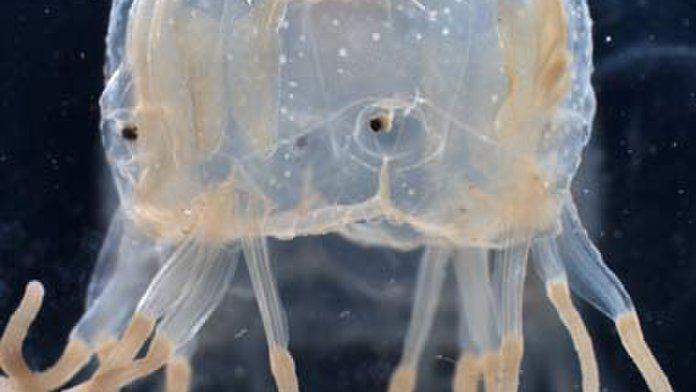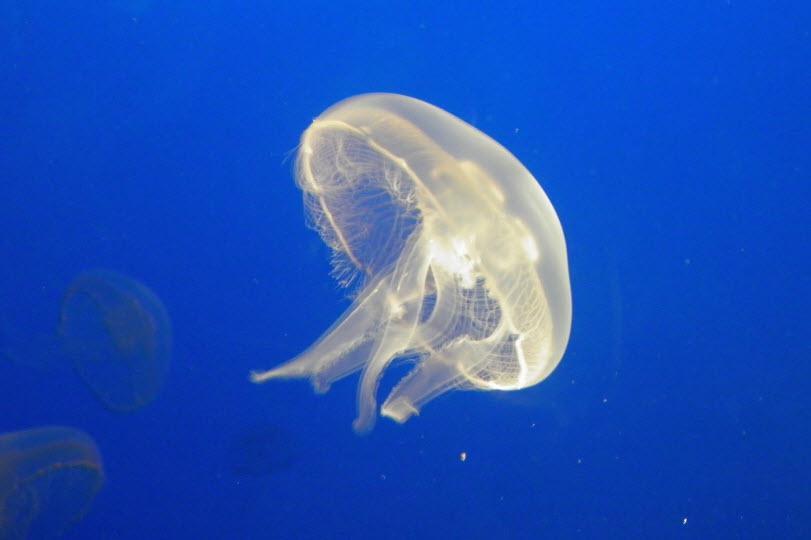The first image is the image on the left, the second image is the image on the right. Assess this claim about the two images: "There is a scuba diver with an airtank swimming with a jellyfish.". Correct or not? Answer yes or no. No. 